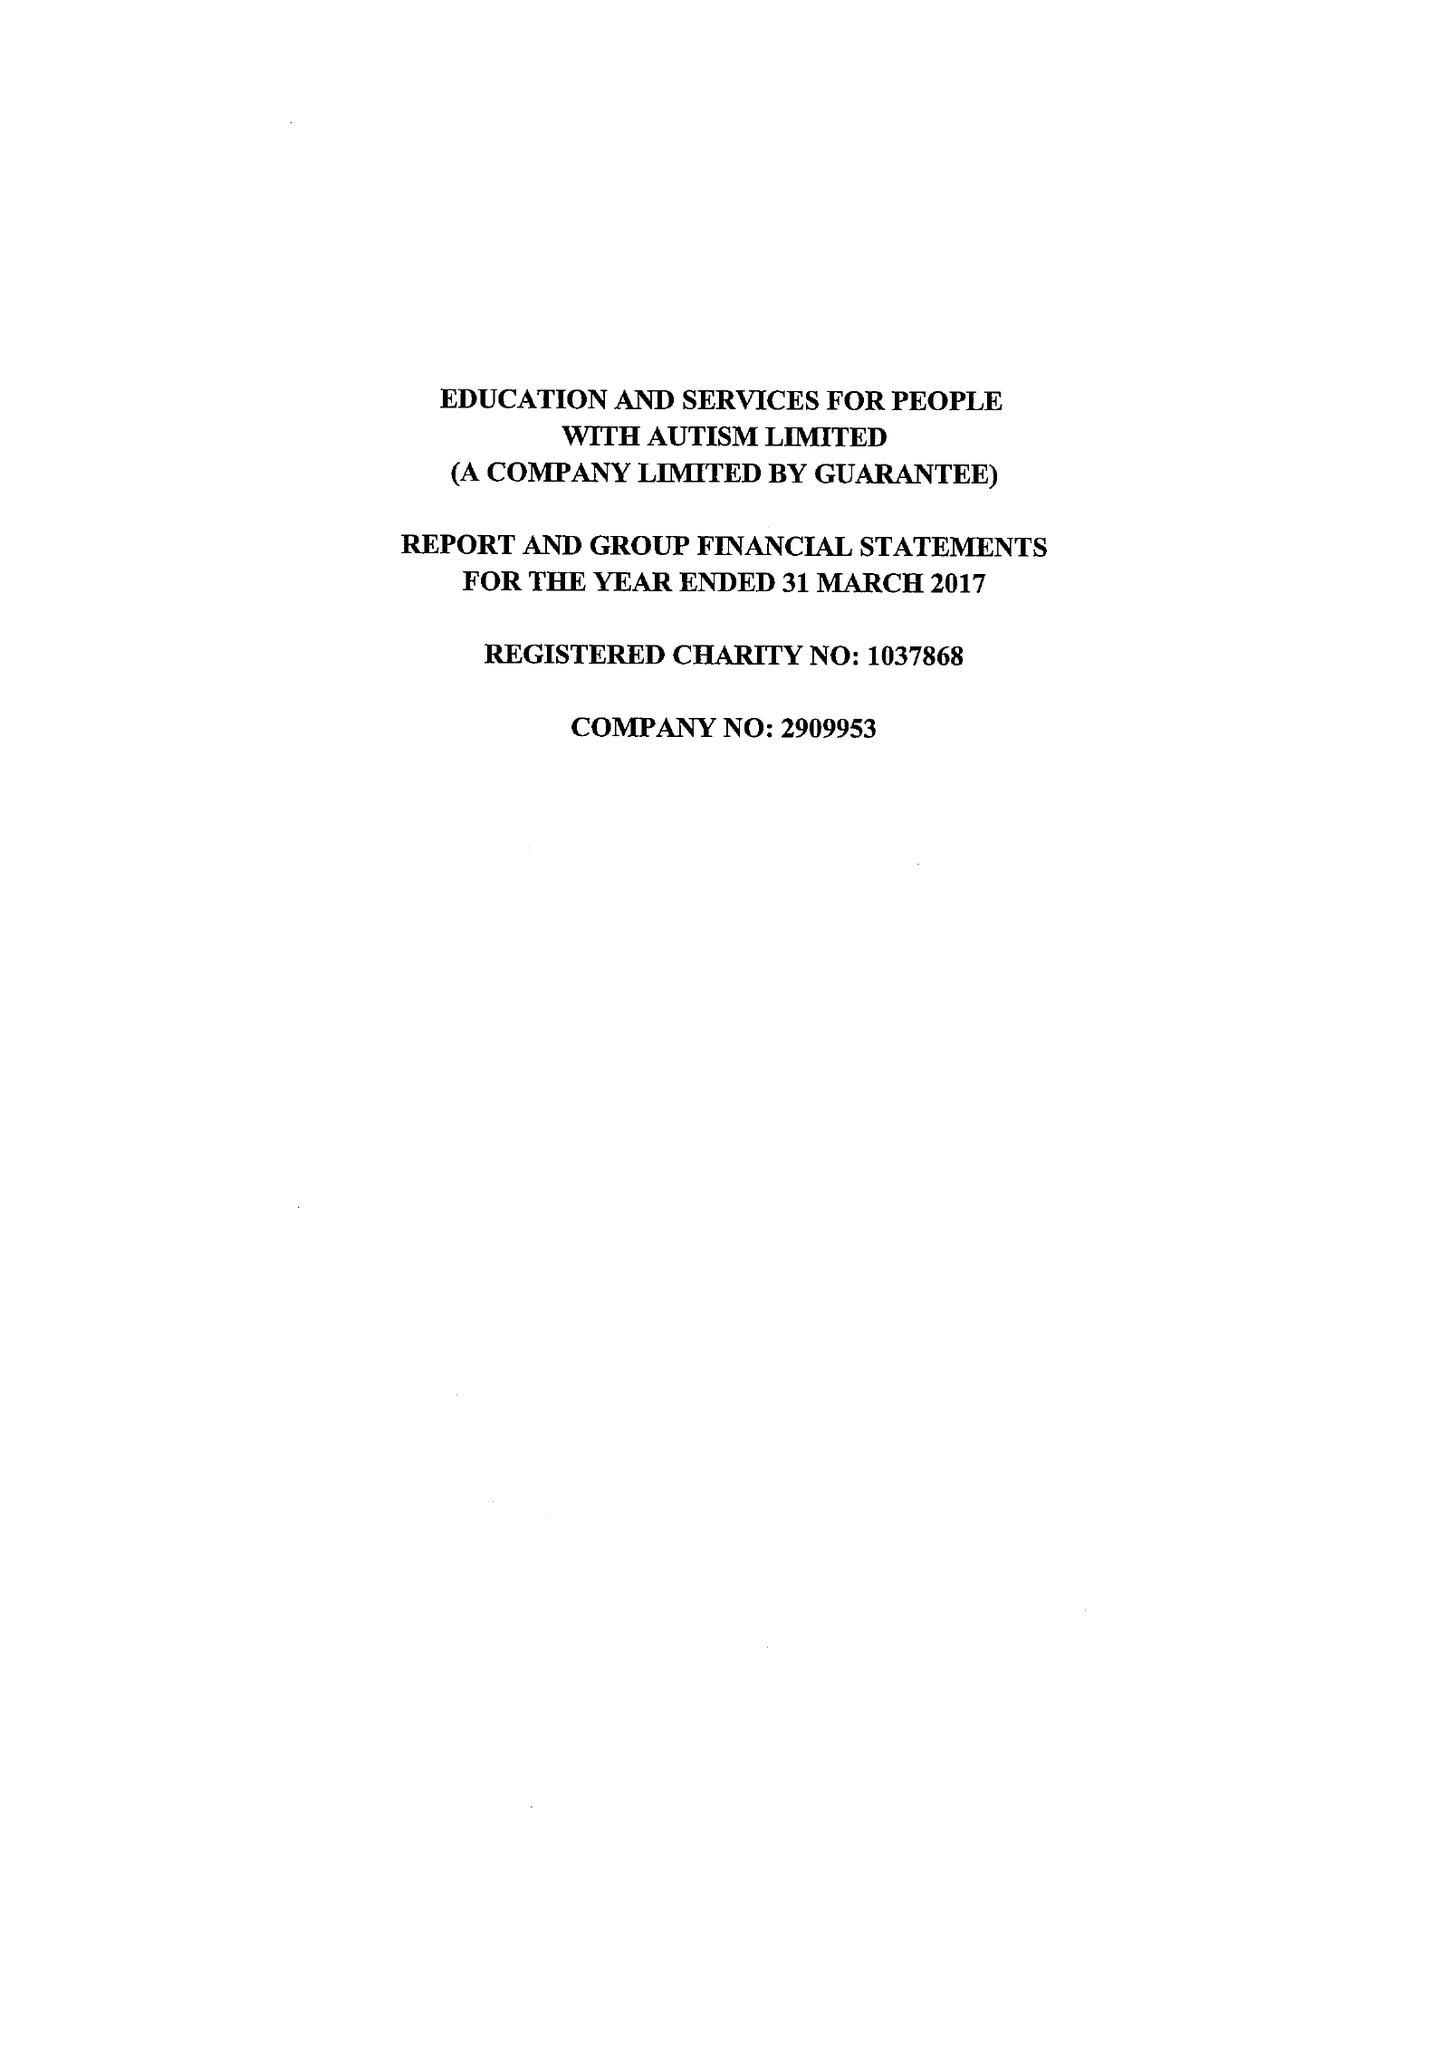What is the value for the charity_number?
Answer the question using a single word or phrase. 1037868 